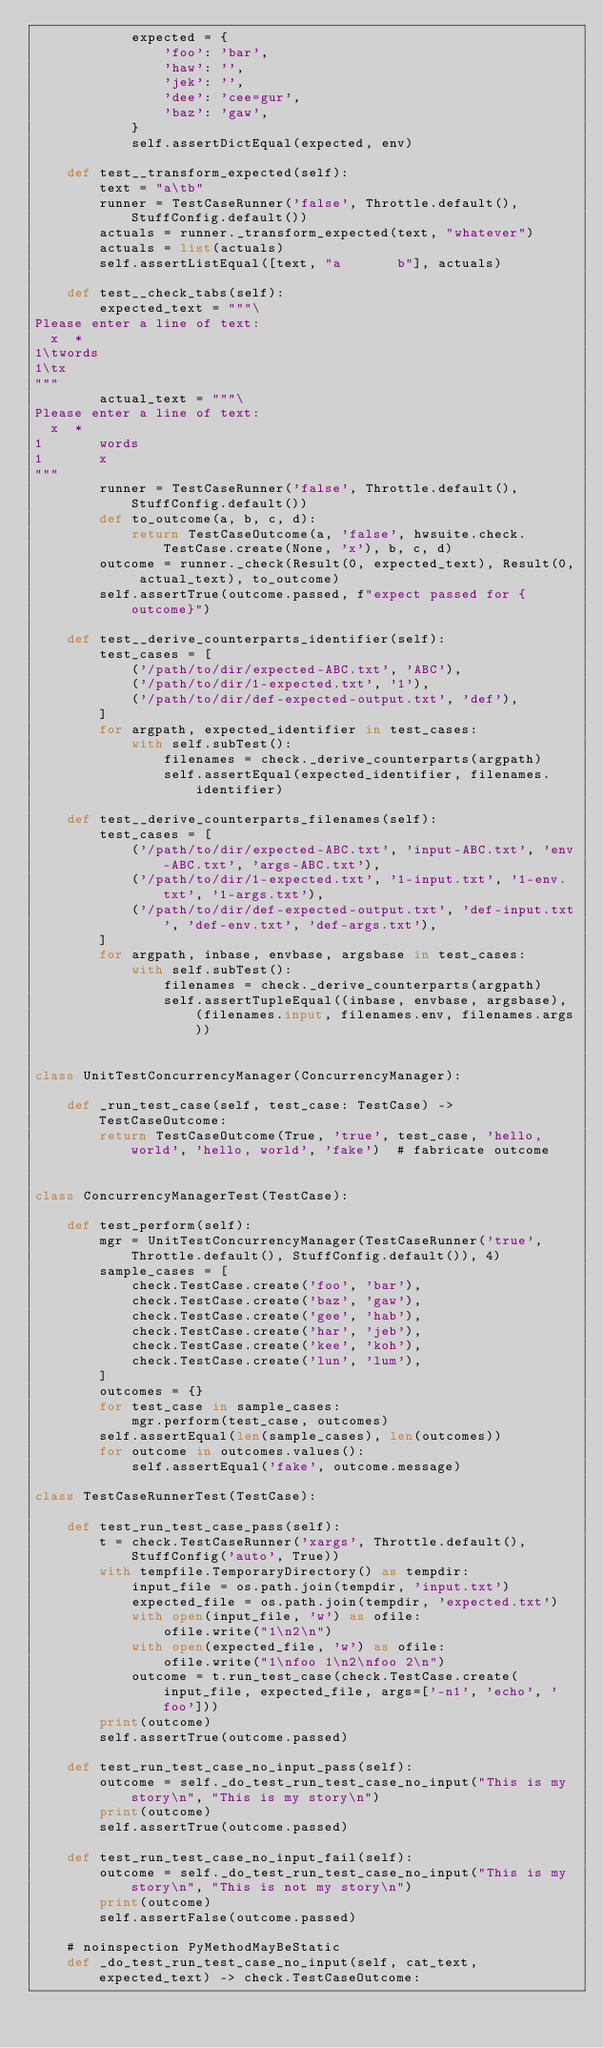Convert code to text. <code><loc_0><loc_0><loc_500><loc_500><_Python_>            expected = {
                'foo': 'bar',
                'haw': '',
                'jek': '',
                'dee': 'cee=gur',
                'baz': 'gaw',
            }
            self.assertDictEqual(expected, env)

    def test__transform_expected(self):
        text = "a\tb"
        runner = TestCaseRunner('false', Throttle.default(), StuffConfig.default())
        actuals = runner._transform_expected(text, "whatever")
        actuals = list(actuals)
        self.assertListEqual([text, "a       b"], actuals)

    def test__check_tabs(self):
        expected_text = """\
Please enter a line of text:
  x  * 
1\twords
1\tx
"""
        actual_text = """\
Please enter a line of text:
  x  * 
1       words
1       x
"""
        runner = TestCaseRunner('false', Throttle.default(), StuffConfig.default())
        def to_outcome(a, b, c, d):
            return TestCaseOutcome(a, 'false', hwsuite.check.TestCase.create(None, 'x'), b, c, d)
        outcome = runner._check(Result(0, expected_text), Result(0, actual_text), to_outcome)
        self.assertTrue(outcome.passed, f"expect passed for {outcome}")

    def test__derive_counterparts_identifier(self):
        test_cases = [
            ('/path/to/dir/expected-ABC.txt', 'ABC'),
            ('/path/to/dir/1-expected.txt', '1'),
            ('/path/to/dir/def-expected-output.txt', 'def'),
        ]
        for argpath, expected_identifier in test_cases:
            with self.subTest():
                filenames = check._derive_counterparts(argpath)
                self.assertEqual(expected_identifier, filenames.identifier)

    def test__derive_counterparts_filenames(self):
        test_cases = [
            ('/path/to/dir/expected-ABC.txt', 'input-ABC.txt', 'env-ABC.txt', 'args-ABC.txt'),
            ('/path/to/dir/1-expected.txt', '1-input.txt', '1-env.txt', '1-args.txt'),
            ('/path/to/dir/def-expected-output.txt', 'def-input.txt', 'def-env.txt', 'def-args.txt'),
        ]
        for argpath, inbase, envbase, argsbase in test_cases:
            with self.subTest():
                filenames = check._derive_counterparts(argpath)
                self.assertTupleEqual((inbase, envbase, argsbase), (filenames.input, filenames.env, filenames.args))


class UnitTestConcurrencyManager(ConcurrencyManager):

    def _run_test_case(self, test_case: TestCase) -> TestCaseOutcome:
        return TestCaseOutcome(True, 'true', test_case, 'hello, world', 'hello, world', 'fake')  # fabricate outcome


class ConcurrencyManagerTest(TestCase):

    def test_perform(self):
        mgr = UnitTestConcurrencyManager(TestCaseRunner('true', Throttle.default(), StuffConfig.default()), 4)
        sample_cases = [
            check.TestCase.create('foo', 'bar'),
            check.TestCase.create('baz', 'gaw'),
            check.TestCase.create('gee', 'hab'),
            check.TestCase.create('har', 'jeb'),
            check.TestCase.create('kee', 'koh'),
            check.TestCase.create('lun', 'lum'),
        ]
        outcomes = {}
        for test_case in sample_cases:
            mgr.perform(test_case, outcomes)
        self.assertEqual(len(sample_cases), len(outcomes))
        for outcome in outcomes.values():
            self.assertEqual('fake', outcome.message)

class TestCaseRunnerTest(TestCase):

    def test_run_test_case_pass(self):
        t = check.TestCaseRunner('xargs', Throttle.default(), StuffConfig('auto', True))
        with tempfile.TemporaryDirectory() as tempdir:
            input_file = os.path.join(tempdir, 'input.txt')
            expected_file = os.path.join(tempdir, 'expected.txt')
            with open(input_file, 'w') as ofile:
                ofile.write("1\n2\n")
            with open(expected_file, 'w') as ofile:
                ofile.write("1\nfoo 1\n2\nfoo 2\n")
            outcome = t.run_test_case(check.TestCase.create(input_file, expected_file, args=['-n1', 'echo', 'foo']))
        print(outcome)
        self.assertTrue(outcome.passed)

    def test_run_test_case_no_input_pass(self):
        outcome = self._do_test_run_test_case_no_input("This is my story\n", "This is my story\n")
        print(outcome)
        self.assertTrue(outcome.passed)

    def test_run_test_case_no_input_fail(self):
        outcome = self._do_test_run_test_case_no_input("This is my story\n", "This is not my story\n")
        print(outcome)
        self.assertFalse(outcome.passed)

    # noinspection PyMethodMayBeStatic
    def _do_test_run_test_case_no_input(self, cat_text, expected_text) -> check.TestCaseOutcome:</code> 